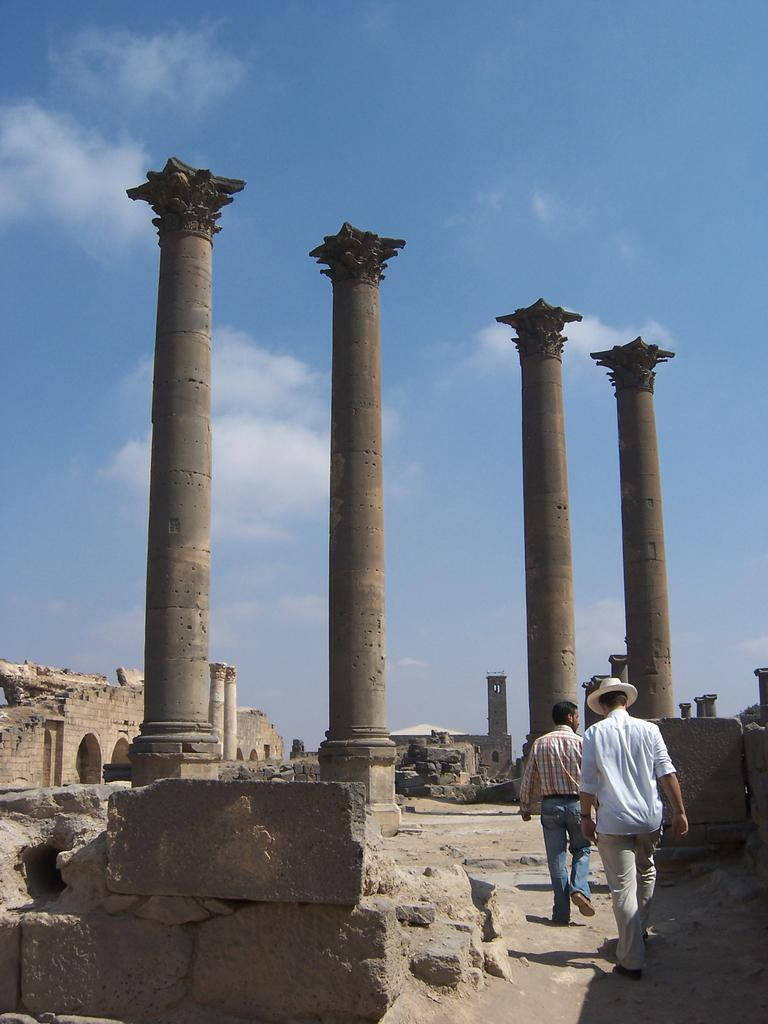How many men are in the image? There are two men in the image. What are the men doing in the image? The men are standing and walking on the floor. What architectural features can be seen in the image? There are four huge pillars in the image. What is visible behind the pillars? There are buildings behind the pillars. What can be seen in the sky in the image? The sky is visible in the image, and clouds are present. Where is the nest located in the image? There is no nest present in the image. What type of question is being asked in the image? There is no question being asked in the image. 